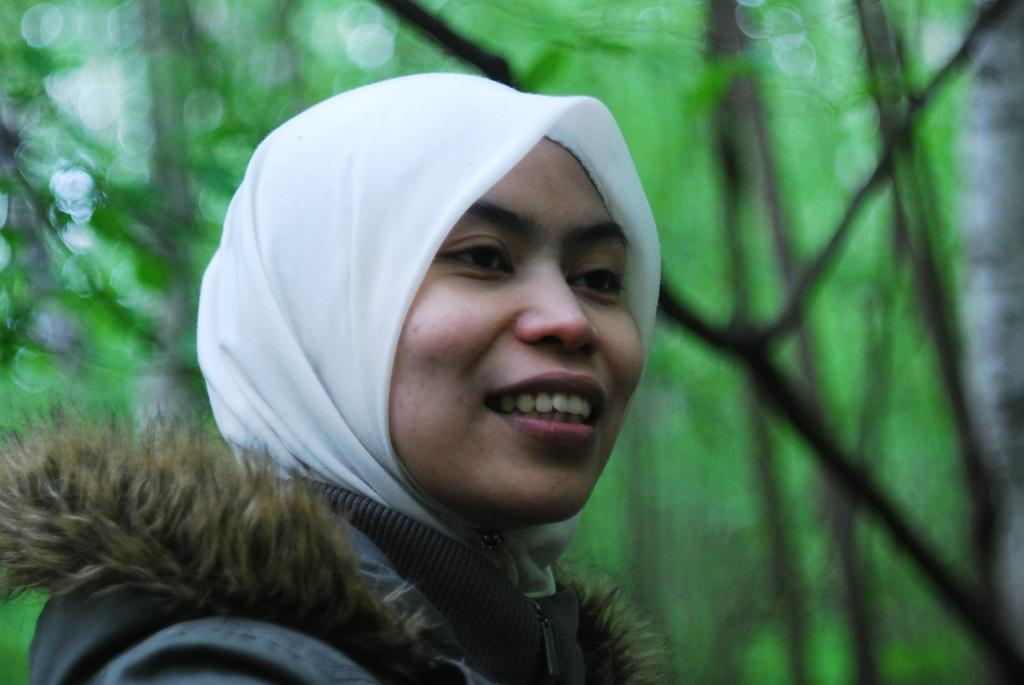Who is present in the image? There is a woman in the image. What is the woman's facial expression? The woman is smiling. What can be seen in the background of the image? There are trees visible in the background of the image. How would you describe the background of the image? The background of the image is blurred. What type of scarf is the woman wearing in the image? There is no scarf visible in the image. How many cherries can be seen on the woman's head in the image? There are no cherries present in the image. 